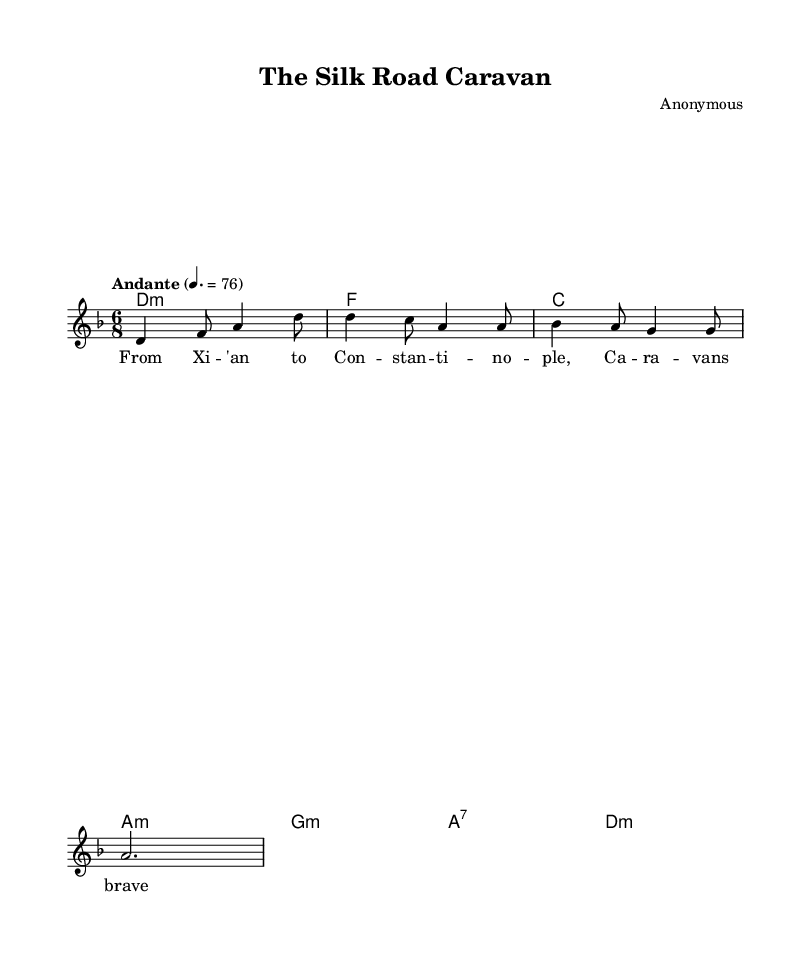What is the time signature of this music? The time signature is located at the beginning of the sheet music, represented as 6/8, indicating that there are six eighth-note beats in each measure.
Answer: 6/8 What is the key signature of this music? The key signature is shown at the beginning of the score, which is D minor, indicated by one flat (B flat).
Answer: D minor What is the tempo marking of this piece? The tempo marking is displayed above the staff, stating "Andante" with a metronome marking of 76, which suggests a moderate pace.
Answer: Andante How many measures are there in the melody? The melody is analyzed by counting the groups of notes and rests, resulting in a total of four measures in the provided section.
Answer: 4 What is the first note of the melody? The first note can be found at the beginning of the melody line and is identified as D in the relative position, making it the starting pitch.
Answer: D What is the third chord in the harmony? To find the third chord, one counts the chords displayed beneath the staff, which reveals that the third chord is a C major chord.
Answer: C major What is the theme of the lyrics in this song? The lyrics reference travel, with the first line mentioning a journey from Xi'an to Constantinople, emphasizing the historical trade route theme.
Answer: Trade routes 